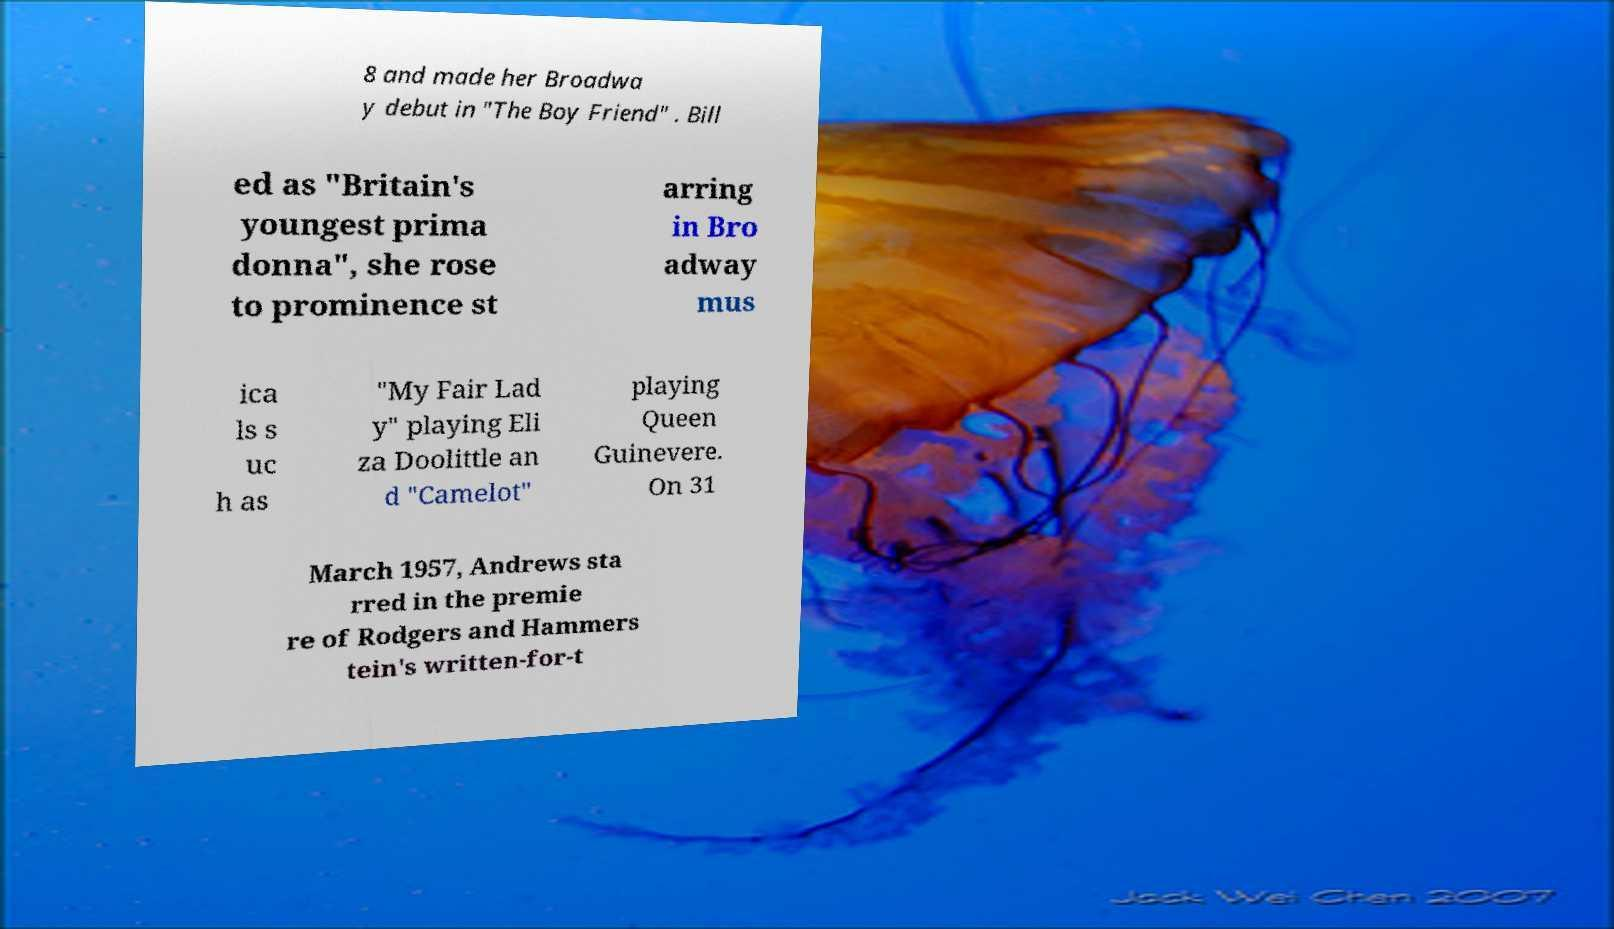What messages or text are displayed in this image? I need them in a readable, typed format. 8 and made her Broadwa y debut in "The Boy Friend" . Bill ed as "Britain's youngest prima donna", she rose to prominence st arring in Bro adway mus ica ls s uc h as "My Fair Lad y" playing Eli za Doolittle an d "Camelot" playing Queen Guinevere. On 31 March 1957, Andrews sta rred in the premie re of Rodgers and Hammers tein's written-for-t 